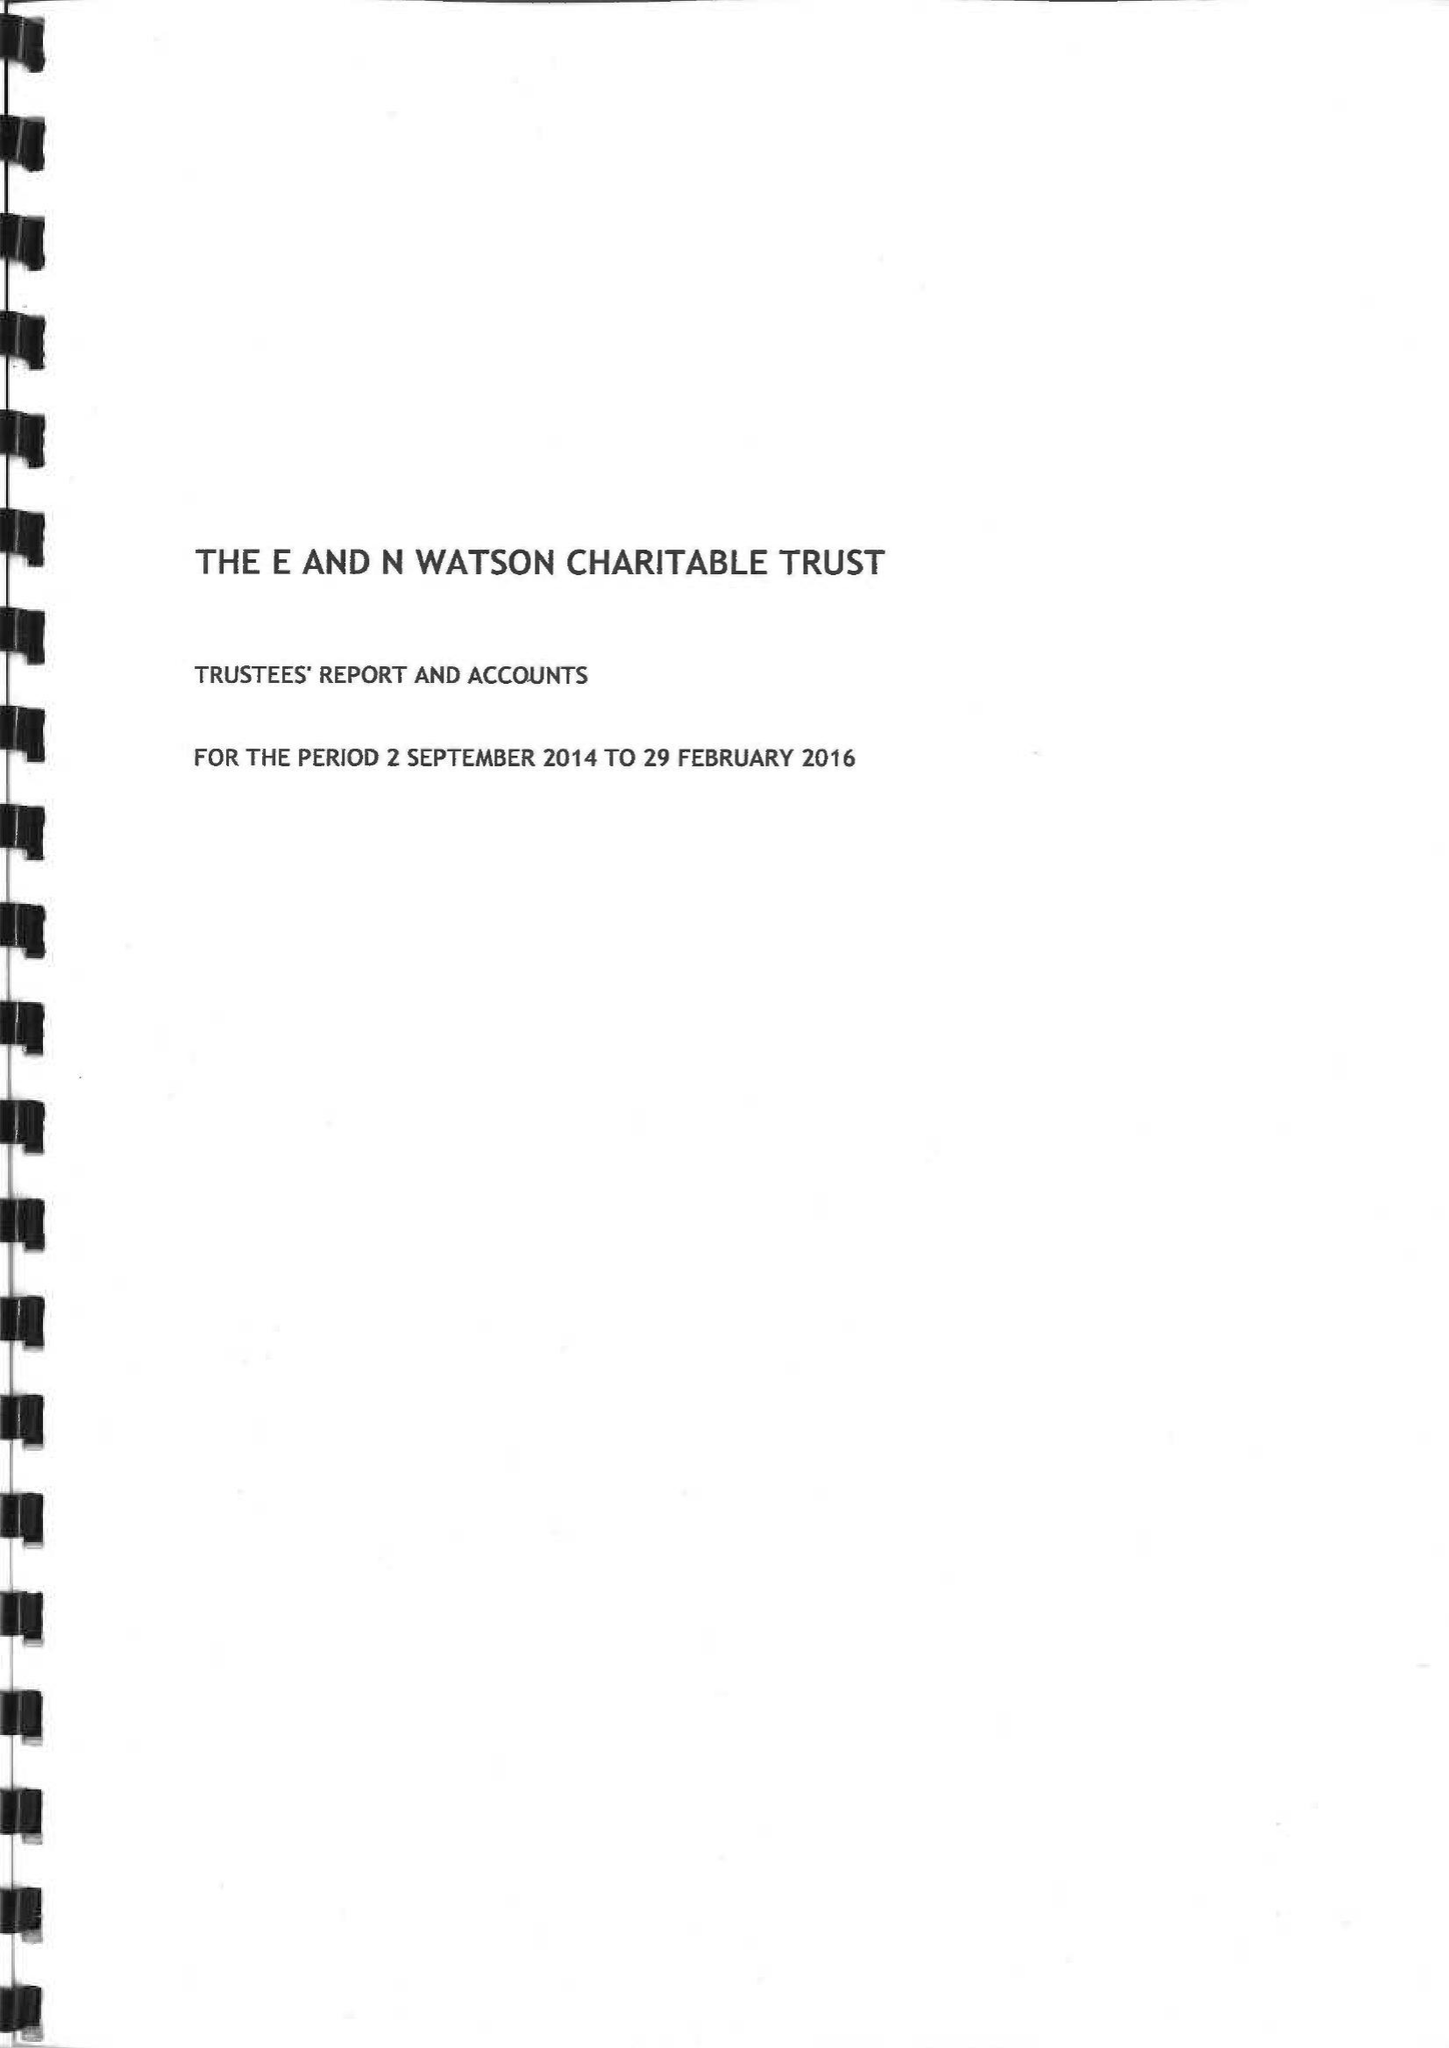What is the value for the address__post_town?
Answer the question using a single word or phrase. SALISBURY 